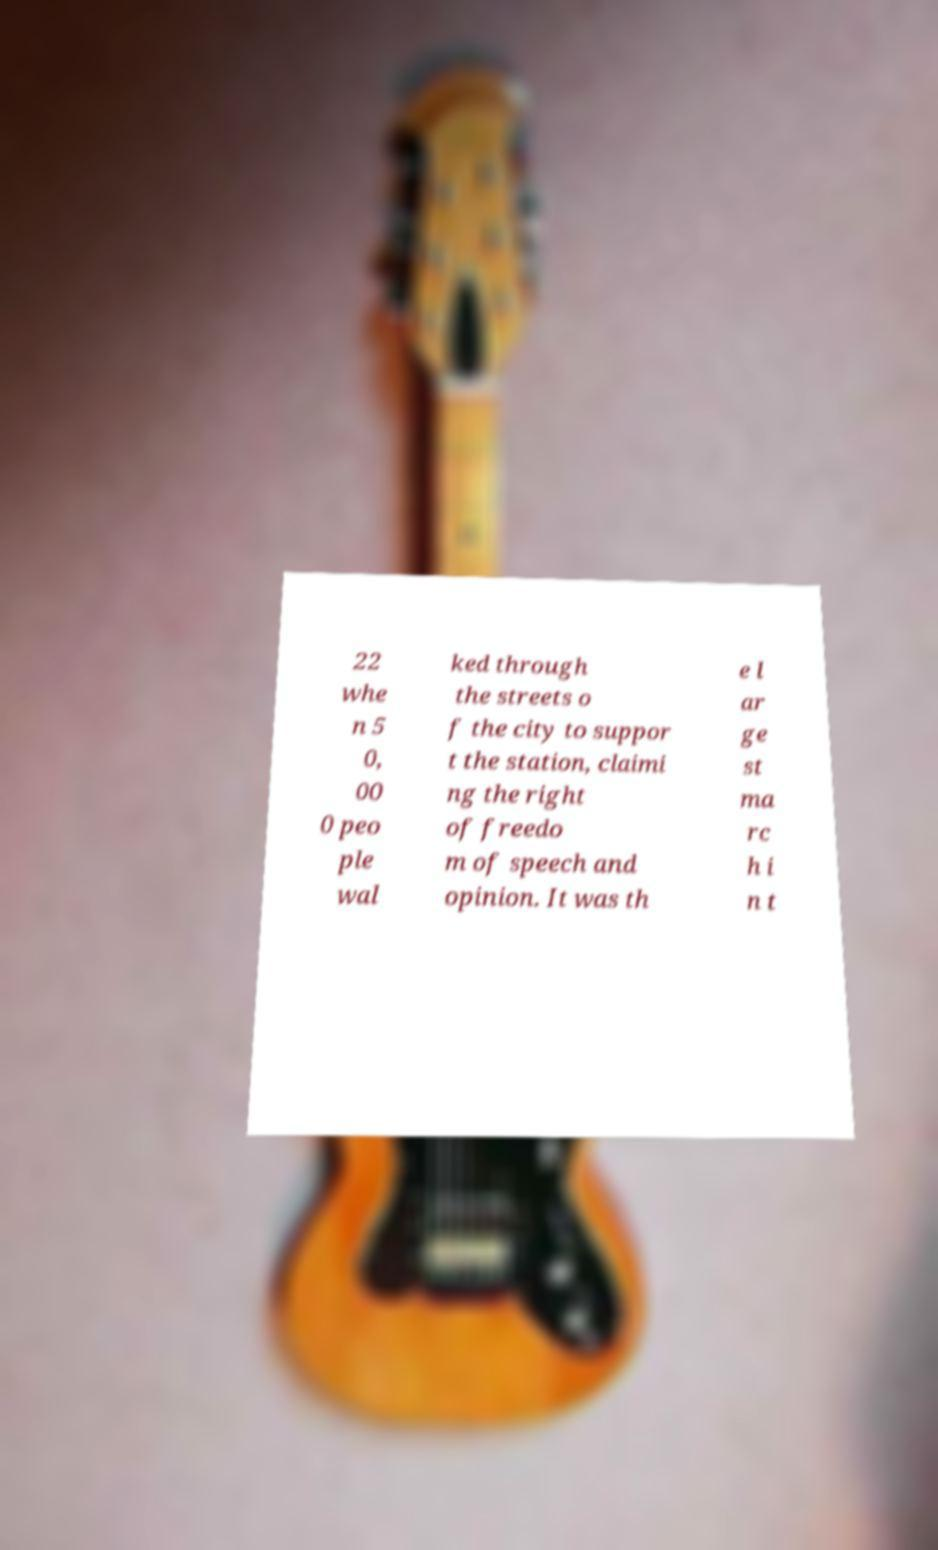I need the written content from this picture converted into text. Can you do that? 22 whe n 5 0, 00 0 peo ple wal ked through the streets o f the city to suppor t the station, claimi ng the right of freedo m of speech and opinion. It was th e l ar ge st ma rc h i n t 